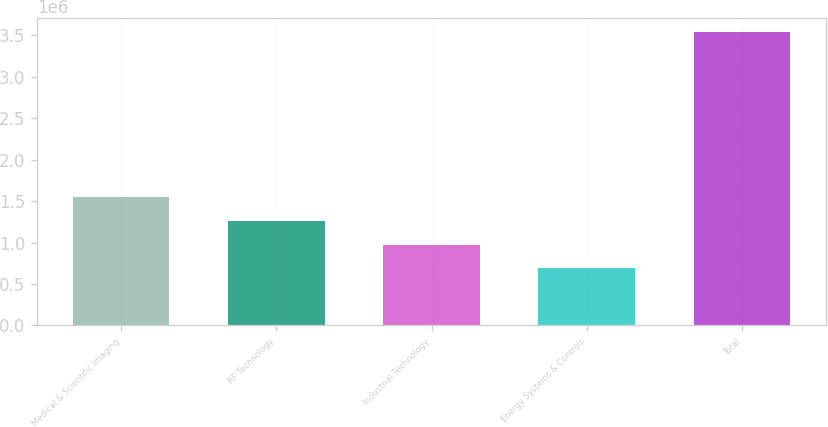Convert chart. <chart><loc_0><loc_0><loc_500><loc_500><bar_chart><fcel>Medical & Scientific Imaging<fcel>RF Technology<fcel>Industrial Technology<fcel>Energy Systems & Controls<fcel>Total<nl><fcel>1.54592e+06<fcel>1.26132e+06<fcel>976730<fcel>692136<fcel>3.53808e+06<nl></chart> 